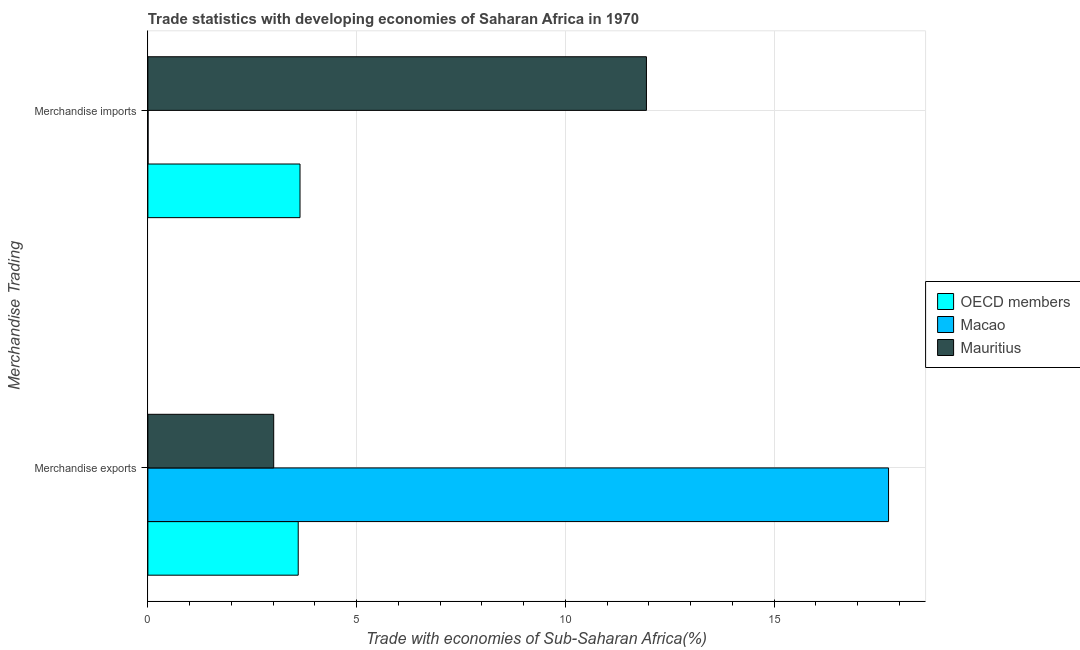How many different coloured bars are there?
Your answer should be very brief. 3. Are the number of bars on each tick of the Y-axis equal?
Make the answer very short. Yes. What is the merchandise imports in Mauritius?
Keep it short and to the point. 11.94. Across all countries, what is the maximum merchandise imports?
Your response must be concise. 11.94. Across all countries, what is the minimum merchandise imports?
Keep it short and to the point. 0. In which country was the merchandise imports maximum?
Your answer should be compact. Mauritius. In which country was the merchandise exports minimum?
Your answer should be compact. Mauritius. What is the total merchandise exports in the graph?
Give a very brief answer. 24.36. What is the difference between the merchandise imports in Macao and that in OECD members?
Provide a short and direct response. -3.64. What is the difference between the merchandise exports in OECD members and the merchandise imports in Macao?
Make the answer very short. 3.6. What is the average merchandise imports per country?
Offer a very short reply. 5.2. What is the difference between the merchandise imports and merchandise exports in Macao?
Make the answer very short. -17.74. In how many countries, is the merchandise exports greater than 2 %?
Provide a short and direct response. 3. What is the ratio of the merchandise exports in OECD members to that in Mauritius?
Your answer should be very brief. 1.19. Is the merchandise exports in OECD members less than that in Mauritius?
Provide a short and direct response. No. In how many countries, is the merchandise imports greater than the average merchandise imports taken over all countries?
Make the answer very short. 1. What does the 1st bar from the top in Merchandise imports represents?
Your response must be concise. Mauritius. What does the 2nd bar from the bottom in Merchandise exports represents?
Keep it short and to the point. Macao. Are all the bars in the graph horizontal?
Make the answer very short. Yes. How many countries are there in the graph?
Ensure brevity in your answer.  3. What is the difference between two consecutive major ticks on the X-axis?
Your response must be concise. 5. Does the graph contain any zero values?
Provide a short and direct response. No. Does the graph contain grids?
Your answer should be compact. Yes. Where does the legend appear in the graph?
Your answer should be very brief. Center right. How many legend labels are there?
Your answer should be compact. 3. How are the legend labels stacked?
Offer a terse response. Vertical. What is the title of the graph?
Your answer should be very brief. Trade statistics with developing economies of Saharan Africa in 1970. What is the label or title of the X-axis?
Give a very brief answer. Trade with economies of Sub-Saharan Africa(%). What is the label or title of the Y-axis?
Offer a terse response. Merchandise Trading. What is the Trade with economies of Sub-Saharan Africa(%) of OECD members in Merchandise exports?
Your response must be concise. 3.6. What is the Trade with economies of Sub-Saharan Africa(%) in Macao in Merchandise exports?
Keep it short and to the point. 17.74. What is the Trade with economies of Sub-Saharan Africa(%) in Mauritius in Merchandise exports?
Offer a very short reply. 3.01. What is the Trade with economies of Sub-Saharan Africa(%) in OECD members in Merchandise imports?
Your response must be concise. 3.64. What is the Trade with economies of Sub-Saharan Africa(%) in Macao in Merchandise imports?
Provide a succinct answer. 0. What is the Trade with economies of Sub-Saharan Africa(%) in Mauritius in Merchandise imports?
Provide a succinct answer. 11.94. Across all Merchandise Trading, what is the maximum Trade with economies of Sub-Saharan Africa(%) of OECD members?
Provide a succinct answer. 3.64. Across all Merchandise Trading, what is the maximum Trade with economies of Sub-Saharan Africa(%) of Macao?
Keep it short and to the point. 17.74. Across all Merchandise Trading, what is the maximum Trade with economies of Sub-Saharan Africa(%) of Mauritius?
Provide a short and direct response. 11.94. Across all Merchandise Trading, what is the minimum Trade with economies of Sub-Saharan Africa(%) of OECD members?
Provide a short and direct response. 3.6. Across all Merchandise Trading, what is the minimum Trade with economies of Sub-Saharan Africa(%) in Macao?
Make the answer very short. 0. Across all Merchandise Trading, what is the minimum Trade with economies of Sub-Saharan Africa(%) in Mauritius?
Ensure brevity in your answer.  3.01. What is the total Trade with economies of Sub-Saharan Africa(%) of OECD members in the graph?
Ensure brevity in your answer.  7.25. What is the total Trade with economies of Sub-Saharan Africa(%) in Macao in the graph?
Make the answer very short. 17.75. What is the total Trade with economies of Sub-Saharan Africa(%) in Mauritius in the graph?
Give a very brief answer. 14.96. What is the difference between the Trade with economies of Sub-Saharan Africa(%) of OECD members in Merchandise exports and that in Merchandise imports?
Your response must be concise. -0.04. What is the difference between the Trade with economies of Sub-Saharan Africa(%) in Macao in Merchandise exports and that in Merchandise imports?
Your answer should be compact. 17.74. What is the difference between the Trade with economies of Sub-Saharan Africa(%) in Mauritius in Merchandise exports and that in Merchandise imports?
Make the answer very short. -8.93. What is the difference between the Trade with economies of Sub-Saharan Africa(%) in OECD members in Merchandise exports and the Trade with economies of Sub-Saharan Africa(%) in Macao in Merchandise imports?
Provide a succinct answer. 3.6. What is the difference between the Trade with economies of Sub-Saharan Africa(%) of OECD members in Merchandise exports and the Trade with economies of Sub-Saharan Africa(%) of Mauritius in Merchandise imports?
Give a very brief answer. -8.34. What is the difference between the Trade with economies of Sub-Saharan Africa(%) in Macao in Merchandise exports and the Trade with economies of Sub-Saharan Africa(%) in Mauritius in Merchandise imports?
Offer a very short reply. 5.8. What is the average Trade with economies of Sub-Saharan Africa(%) of OECD members per Merchandise Trading?
Offer a terse response. 3.62. What is the average Trade with economies of Sub-Saharan Africa(%) of Macao per Merchandise Trading?
Offer a very short reply. 8.87. What is the average Trade with economies of Sub-Saharan Africa(%) of Mauritius per Merchandise Trading?
Offer a very short reply. 7.48. What is the difference between the Trade with economies of Sub-Saharan Africa(%) in OECD members and Trade with economies of Sub-Saharan Africa(%) in Macao in Merchandise exports?
Your response must be concise. -14.14. What is the difference between the Trade with economies of Sub-Saharan Africa(%) in OECD members and Trade with economies of Sub-Saharan Africa(%) in Mauritius in Merchandise exports?
Offer a very short reply. 0.59. What is the difference between the Trade with economies of Sub-Saharan Africa(%) of Macao and Trade with economies of Sub-Saharan Africa(%) of Mauritius in Merchandise exports?
Provide a short and direct response. 14.73. What is the difference between the Trade with economies of Sub-Saharan Africa(%) of OECD members and Trade with economies of Sub-Saharan Africa(%) of Macao in Merchandise imports?
Offer a very short reply. 3.64. What is the difference between the Trade with economies of Sub-Saharan Africa(%) of OECD members and Trade with economies of Sub-Saharan Africa(%) of Mauritius in Merchandise imports?
Offer a very short reply. -8.3. What is the difference between the Trade with economies of Sub-Saharan Africa(%) of Macao and Trade with economies of Sub-Saharan Africa(%) of Mauritius in Merchandise imports?
Provide a succinct answer. -11.94. What is the ratio of the Trade with economies of Sub-Saharan Africa(%) of Macao in Merchandise exports to that in Merchandise imports?
Provide a short and direct response. 3843.39. What is the ratio of the Trade with economies of Sub-Saharan Africa(%) in Mauritius in Merchandise exports to that in Merchandise imports?
Make the answer very short. 0.25. What is the difference between the highest and the second highest Trade with economies of Sub-Saharan Africa(%) of OECD members?
Provide a short and direct response. 0.04. What is the difference between the highest and the second highest Trade with economies of Sub-Saharan Africa(%) of Macao?
Ensure brevity in your answer.  17.74. What is the difference between the highest and the second highest Trade with economies of Sub-Saharan Africa(%) of Mauritius?
Offer a very short reply. 8.93. What is the difference between the highest and the lowest Trade with economies of Sub-Saharan Africa(%) in OECD members?
Provide a succinct answer. 0.04. What is the difference between the highest and the lowest Trade with economies of Sub-Saharan Africa(%) of Macao?
Provide a short and direct response. 17.74. What is the difference between the highest and the lowest Trade with economies of Sub-Saharan Africa(%) in Mauritius?
Keep it short and to the point. 8.93. 